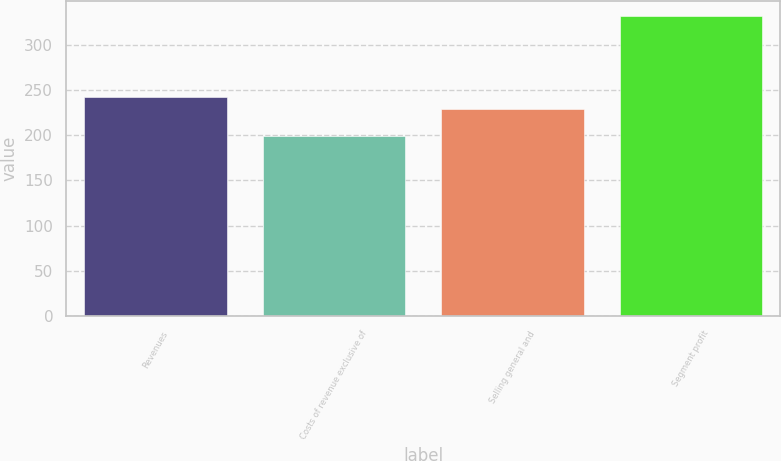Convert chart to OTSL. <chart><loc_0><loc_0><loc_500><loc_500><bar_chart><fcel>Revenues<fcel>Costs of revenue exclusive of<fcel>Selling general and<fcel>Segment profit<nl><fcel>241.75<fcel>199.1<fcel>228.5<fcel>331.6<nl></chart> 